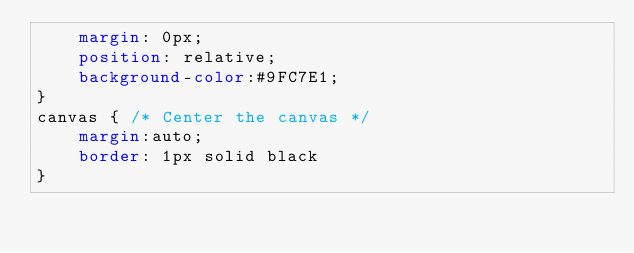<code> <loc_0><loc_0><loc_500><loc_500><_CSS_>	margin: 0px;
	position: relative;
	background-color:#9FC7E1; 
}
canvas { /* Center the canvas */
	margin:auto;
	border: 1px solid black
}</code> 